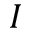Convert formula to latex. <formula><loc_0><loc_0><loc_500><loc_500>I</formula> 